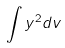<formula> <loc_0><loc_0><loc_500><loc_500>\int y ^ { 2 } d v</formula> 